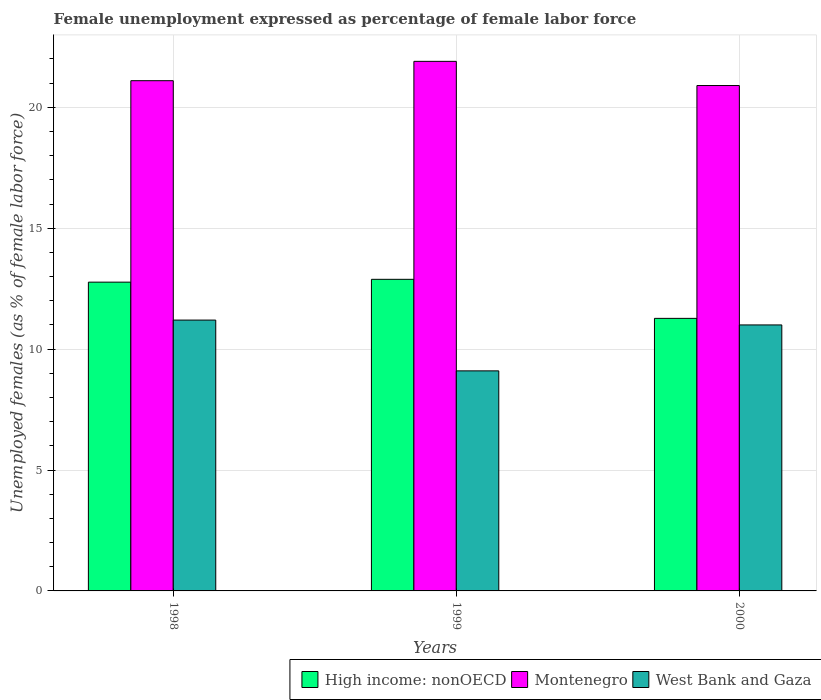How many different coloured bars are there?
Give a very brief answer. 3. Are the number of bars on each tick of the X-axis equal?
Your answer should be very brief. Yes. How many bars are there on the 3rd tick from the left?
Your answer should be compact. 3. In how many cases, is the number of bars for a given year not equal to the number of legend labels?
Offer a terse response. 0. What is the unemployment in females in in Montenegro in 1999?
Provide a succinct answer. 21.9. Across all years, what is the maximum unemployment in females in in West Bank and Gaza?
Provide a short and direct response. 11.2. Across all years, what is the minimum unemployment in females in in High income: nonOECD?
Ensure brevity in your answer.  11.27. What is the total unemployment in females in in High income: nonOECD in the graph?
Give a very brief answer. 36.93. What is the difference between the unemployment in females in in West Bank and Gaza in 1998 and that in 2000?
Offer a terse response. 0.2. What is the difference between the unemployment in females in in West Bank and Gaza in 2000 and the unemployment in females in in Montenegro in 1998?
Offer a very short reply. -10.1. What is the average unemployment in females in in Montenegro per year?
Provide a succinct answer. 21.3. In the year 1998, what is the difference between the unemployment in females in in High income: nonOECD and unemployment in females in in West Bank and Gaza?
Ensure brevity in your answer.  1.57. What is the ratio of the unemployment in females in in High income: nonOECD in 1998 to that in 2000?
Make the answer very short. 1.13. What is the difference between the highest and the second highest unemployment in females in in High income: nonOECD?
Give a very brief answer. 0.12. What is the difference between the highest and the lowest unemployment in females in in Montenegro?
Make the answer very short. 1. What does the 2nd bar from the left in 1999 represents?
Your answer should be very brief. Montenegro. What does the 1st bar from the right in 1999 represents?
Your answer should be very brief. West Bank and Gaza. Is it the case that in every year, the sum of the unemployment in females in in West Bank and Gaza and unemployment in females in in High income: nonOECD is greater than the unemployment in females in in Montenegro?
Give a very brief answer. Yes. How many bars are there?
Keep it short and to the point. 9. How many years are there in the graph?
Provide a succinct answer. 3. What is the difference between two consecutive major ticks on the Y-axis?
Your answer should be very brief. 5. Where does the legend appear in the graph?
Your answer should be compact. Bottom right. How are the legend labels stacked?
Your answer should be compact. Horizontal. What is the title of the graph?
Give a very brief answer. Female unemployment expressed as percentage of female labor force. Does "Belize" appear as one of the legend labels in the graph?
Your answer should be compact. No. What is the label or title of the X-axis?
Offer a terse response. Years. What is the label or title of the Y-axis?
Offer a very short reply. Unemployed females (as % of female labor force). What is the Unemployed females (as % of female labor force) of High income: nonOECD in 1998?
Your response must be concise. 12.77. What is the Unemployed females (as % of female labor force) in Montenegro in 1998?
Your answer should be compact. 21.1. What is the Unemployed females (as % of female labor force) in West Bank and Gaza in 1998?
Your response must be concise. 11.2. What is the Unemployed females (as % of female labor force) of High income: nonOECD in 1999?
Offer a terse response. 12.89. What is the Unemployed females (as % of female labor force) in Montenegro in 1999?
Make the answer very short. 21.9. What is the Unemployed females (as % of female labor force) in West Bank and Gaza in 1999?
Your answer should be very brief. 9.1. What is the Unemployed females (as % of female labor force) of High income: nonOECD in 2000?
Your answer should be compact. 11.27. What is the Unemployed females (as % of female labor force) of Montenegro in 2000?
Give a very brief answer. 20.9. Across all years, what is the maximum Unemployed females (as % of female labor force) of High income: nonOECD?
Make the answer very short. 12.89. Across all years, what is the maximum Unemployed females (as % of female labor force) of Montenegro?
Your response must be concise. 21.9. Across all years, what is the maximum Unemployed females (as % of female labor force) in West Bank and Gaza?
Ensure brevity in your answer.  11.2. Across all years, what is the minimum Unemployed females (as % of female labor force) in High income: nonOECD?
Make the answer very short. 11.27. Across all years, what is the minimum Unemployed females (as % of female labor force) of Montenegro?
Provide a succinct answer. 20.9. Across all years, what is the minimum Unemployed females (as % of female labor force) of West Bank and Gaza?
Offer a terse response. 9.1. What is the total Unemployed females (as % of female labor force) in High income: nonOECD in the graph?
Provide a succinct answer. 36.93. What is the total Unemployed females (as % of female labor force) of Montenegro in the graph?
Ensure brevity in your answer.  63.9. What is the total Unemployed females (as % of female labor force) in West Bank and Gaza in the graph?
Provide a short and direct response. 31.3. What is the difference between the Unemployed females (as % of female labor force) in High income: nonOECD in 1998 and that in 1999?
Provide a succinct answer. -0.12. What is the difference between the Unemployed females (as % of female labor force) of West Bank and Gaza in 1998 and that in 1999?
Make the answer very short. 2.1. What is the difference between the Unemployed females (as % of female labor force) in High income: nonOECD in 1998 and that in 2000?
Give a very brief answer. 1.5. What is the difference between the Unemployed females (as % of female labor force) of High income: nonOECD in 1999 and that in 2000?
Ensure brevity in your answer.  1.61. What is the difference between the Unemployed females (as % of female labor force) of West Bank and Gaza in 1999 and that in 2000?
Ensure brevity in your answer.  -1.9. What is the difference between the Unemployed females (as % of female labor force) in High income: nonOECD in 1998 and the Unemployed females (as % of female labor force) in Montenegro in 1999?
Make the answer very short. -9.13. What is the difference between the Unemployed females (as % of female labor force) in High income: nonOECD in 1998 and the Unemployed females (as % of female labor force) in West Bank and Gaza in 1999?
Ensure brevity in your answer.  3.67. What is the difference between the Unemployed females (as % of female labor force) in Montenegro in 1998 and the Unemployed females (as % of female labor force) in West Bank and Gaza in 1999?
Make the answer very short. 12. What is the difference between the Unemployed females (as % of female labor force) in High income: nonOECD in 1998 and the Unemployed females (as % of female labor force) in Montenegro in 2000?
Give a very brief answer. -8.13. What is the difference between the Unemployed females (as % of female labor force) of High income: nonOECD in 1998 and the Unemployed females (as % of female labor force) of West Bank and Gaza in 2000?
Offer a terse response. 1.77. What is the difference between the Unemployed females (as % of female labor force) of High income: nonOECD in 1999 and the Unemployed females (as % of female labor force) of Montenegro in 2000?
Make the answer very short. -8.01. What is the difference between the Unemployed females (as % of female labor force) in High income: nonOECD in 1999 and the Unemployed females (as % of female labor force) in West Bank and Gaza in 2000?
Your answer should be very brief. 1.89. What is the average Unemployed females (as % of female labor force) in High income: nonOECD per year?
Provide a succinct answer. 12.31. What is the average Unemployed females (as % of female labor force) in Montenegro per year?
Give a very brief answer. 21.3. What is the average Unemployed females (as % of female labor force) in West Bank and Gaza per year?
Provide a short and direct response. 10.43. In the year 1998, what is the difference between the Unemployed females (as % of female labor force) of High income: nonOECD and Unemployed females (as % of female labor force) of Montenegro?
Keep it short and to the point. -8.33. In the year 1998, what is the difference between the Unemployed females (as % of female labor force) of High income: nonOECD and Unemployed females (as % of female labor force) of West Bank and Gaza?
Provide a succinct answer. 1.57. In the year 1998, what is the difference between the Unemployed females (as % of female labor force) of Montenegro and Unemployed females (as % of female labor force) of West Bank and Gaza?
Offer a very short reply. 9.9. In the year 1999, what is the difference between the Unemployed females (as % of female labor force) of High income: nonOECD and Unemployed females (as % of female labor force) of Montenegro?
Provide a succinct answer. -9.01. In the year 1999, what is the difference between the Unemployed females (as % of female labor force) in High income: nonOECD and Unemployed females (as % of female labor force) in West Bank and Gaza?
Provide a succinct answer. 3.79. In the year 2000, what is the difference between the Unemployed females (as % of female labor force) in High income: nonOECD and Unemployed females (as % of female labor force) in Montenegro?
Your answer should be compact. -9.63. In the year 2000, what is the difference between the Unemployed females (as % of female labor force) of High income: nonOECD and Unemployed females (as % of female labor force) of West Bank and Gaza?
Provide a short and direct response. 0.27. In the year 2000, what is the difference between the Unemployed females (as % of female labor force) in Montenegro and Unemployed females (as % of female labor force) in West Bank and Gaza?
Provide a short and direct response. 9.9. What is the ratio of the Unemployed females (as % of female labor force) in High income: nonOECD in 1998 to that in 1999?
Keep it short and to the point. 0.99. What is the ratio of the Unemployed females (as % of female labor force) in Montenegro in 1998 to that in 1999?
Offer a terse response. 0.96. What is the ratio of the Unemployed females (as % of female labor force) of West Bank and Gaza in 1998 to that in 1999?
Ensure brevity in your answer.  1.23. What is the ratio of the Unemployed females (as % of female labor force) of High income: nonOECD in 1998 to that in 2000?
Ensure brevity in your answer.  1.13. What is the ratio of the Unemployed females (as % of female labor force) of Montenegro in 1998 to that in 2000?
Your answer should be compact. 1.01. What is the ratio of the Unemployed females (as % of female labor force) of West Bank and Gaza in 1998 to that in 2000?
Your response must be concise. 1.02. What is the ratio of the Unemployed females (as % of female labor force) in High income: nonOECD in 1999 to that in 2000?
Make the answer very short. 1.14. What is the ratio of the Unemployed females (as % of female labor force) of Montenegro in 1999 to that in 2000?
Your answer should be compact. 1.05. What is the ratio of the Unemployed females (as % of female labor force) in West Bank and Gaza in 1999 to that in 2000?
Ensure brevity in your answer.  0.83. What is the difference between the highest and the second highest Unemployed females (as % of female labor force) of High income: nonOECD?
Keep it short and to the point. 0.12. What is the difference between the highest and the second highest Unemployed females (as % of female labor force) in West Bank and Gaza?
Give a very brief answer. 0.2. What is the difference between the highest and the lowest Unemployed females (as % of female labor force) of High income: nonOECD?
Offer a very short reply. 1.61. 